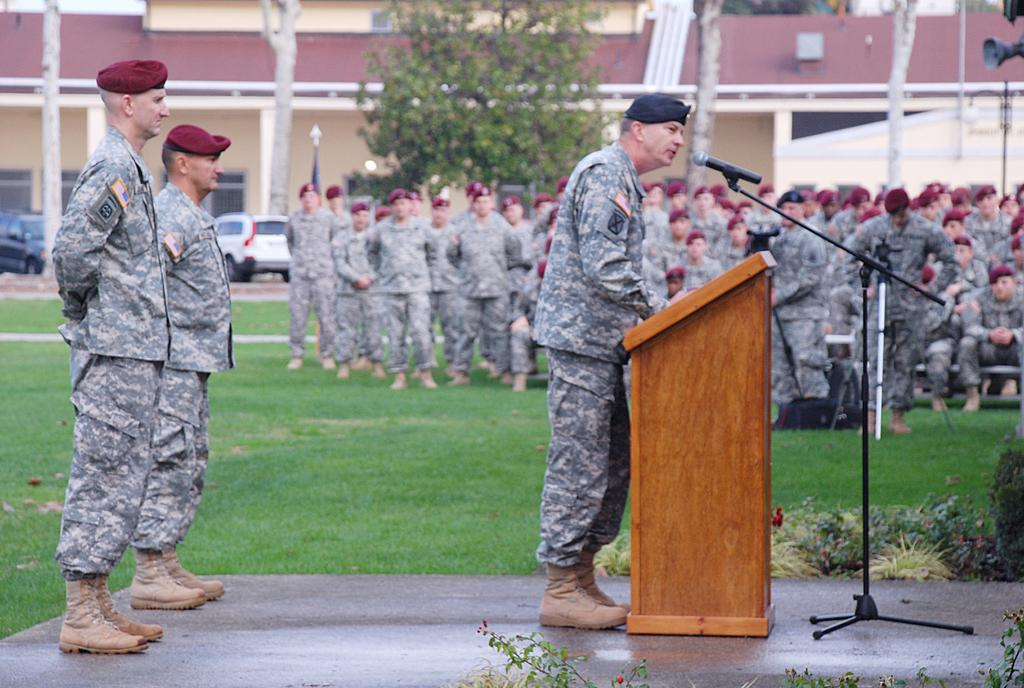What is the main subject of the image? The main subject of the image is a group of people. What are the people in the image wearing? The people are wearing army dress. What is the man in the image doing? The man is talking on a microphone. What type of terrain is visible in the image? There is grass in the image. Are there any animals present in the image? Yes, there are cats in the image. What other structures can be seen in the image? There is a tree and a building in the image. What rule is the group of people following in the image? There is no specific rule mentioned or depicted in the image; it simply shows a group of people wearing army dress and a man talking on a microphone. How many spiders can be seen crawling on the tree in the image? There are no spiders visible in the image; it only shows a tree and a group of people. 